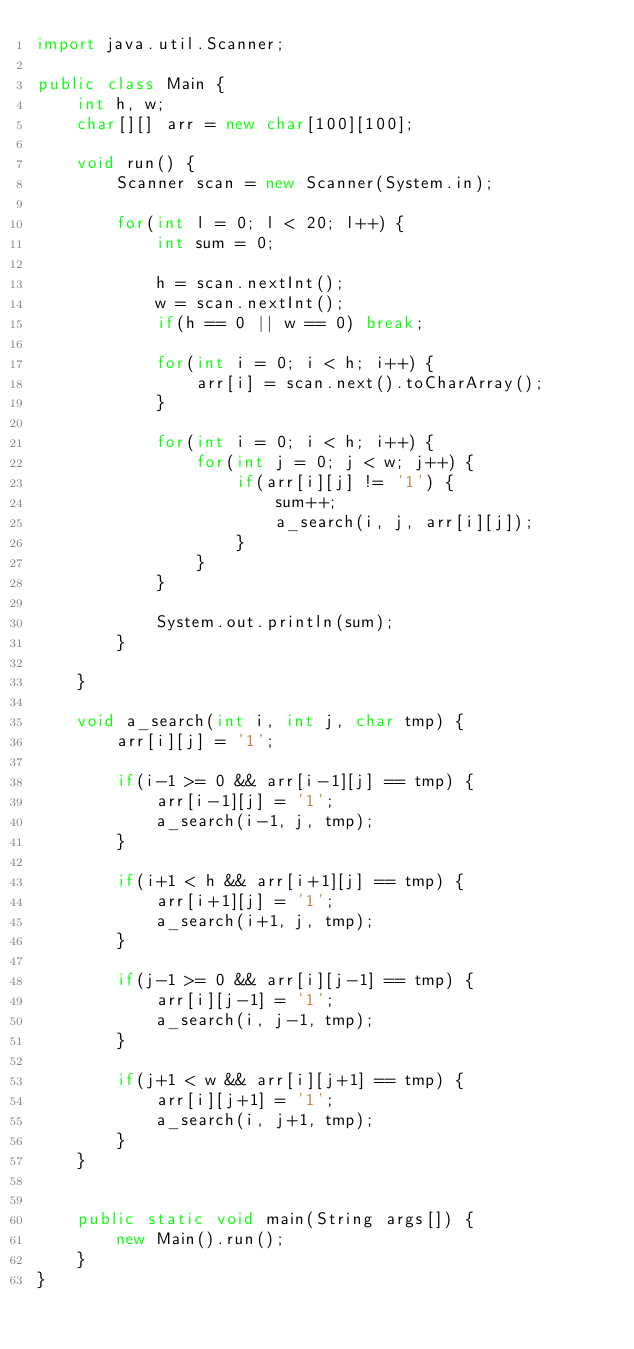<code> <loc_0><loc_0><loc_500><loc_500><_Java_>import java.util.Scanner;

public class Main {
	int h, w;
	char[][] arr = new char[100][100];
	
	void run() {
		Scanner scan = new Scanner(System.in);
		
		for(int l = 0; l < 20; l++) {
			int sum = 0;
			
			h = scan.nextInt();
			w = scan.nextInt();
			if(h == 0 || w == 0) break;
			
			for(int i = 0; i < h; i++) {
				arr[i] = scan.next().toCharArray();
			}
			
			for(int i = 0; i < h; i++) {
				for(int j = 0; j < w; j++) {
					if(arr[i][j] != '1') {
						sum++;
						a_search(i, j, arr[i][j]);
					}
				}
			}			
			
			System.out.println(sum);
		}
		
	}
	
	void a_search(int i, int j, char tmp) {
		arr[i][j] = '1';
		
		if(i-1 >= 0 && arr[i-1][j] == tmp) {
			arr[i-1][j] = '1';
			a_search(i-1, j, tmp);
		}
		
		if(i+1 < h && arr[i+1][j] == tmp) {
			arr[i+1][j] = '1';
			a_search(i+1, j, tmp);
		}
		
		if(j-1 >= 0 && arr[i][j-1] == tmp) {
			arr[i][j-1] = '1';
			a_search(i, j-1, tmp);
		}
		
		if(j+1 < w && arr[i][j+1] == tmp) {
			arr[i][j+1] = '1';
			a_search(i, j+1, tmp);
		}
	}
	
	
	public static void main(String args[]) {
		new Main().run();
	}
}

</code> 